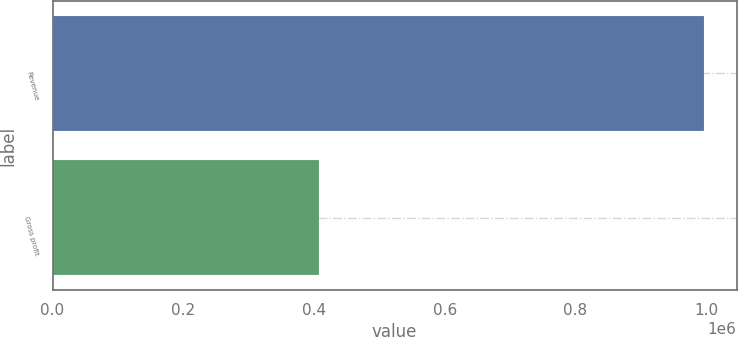Convert chart to OTSL. <chart><loc_0><loc_0><loc_500><loc_500><bar_chart><fcel>Revenue<fcel>Gross profit<nl><fcel>996668<fcel>407600<nl></chart> 